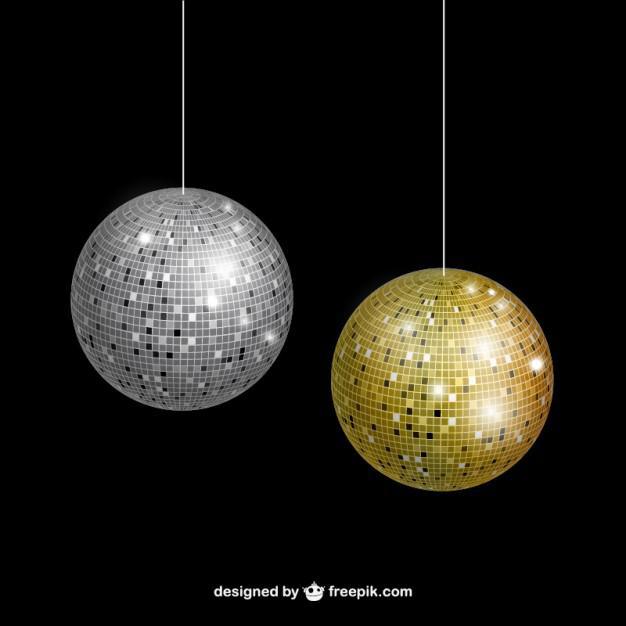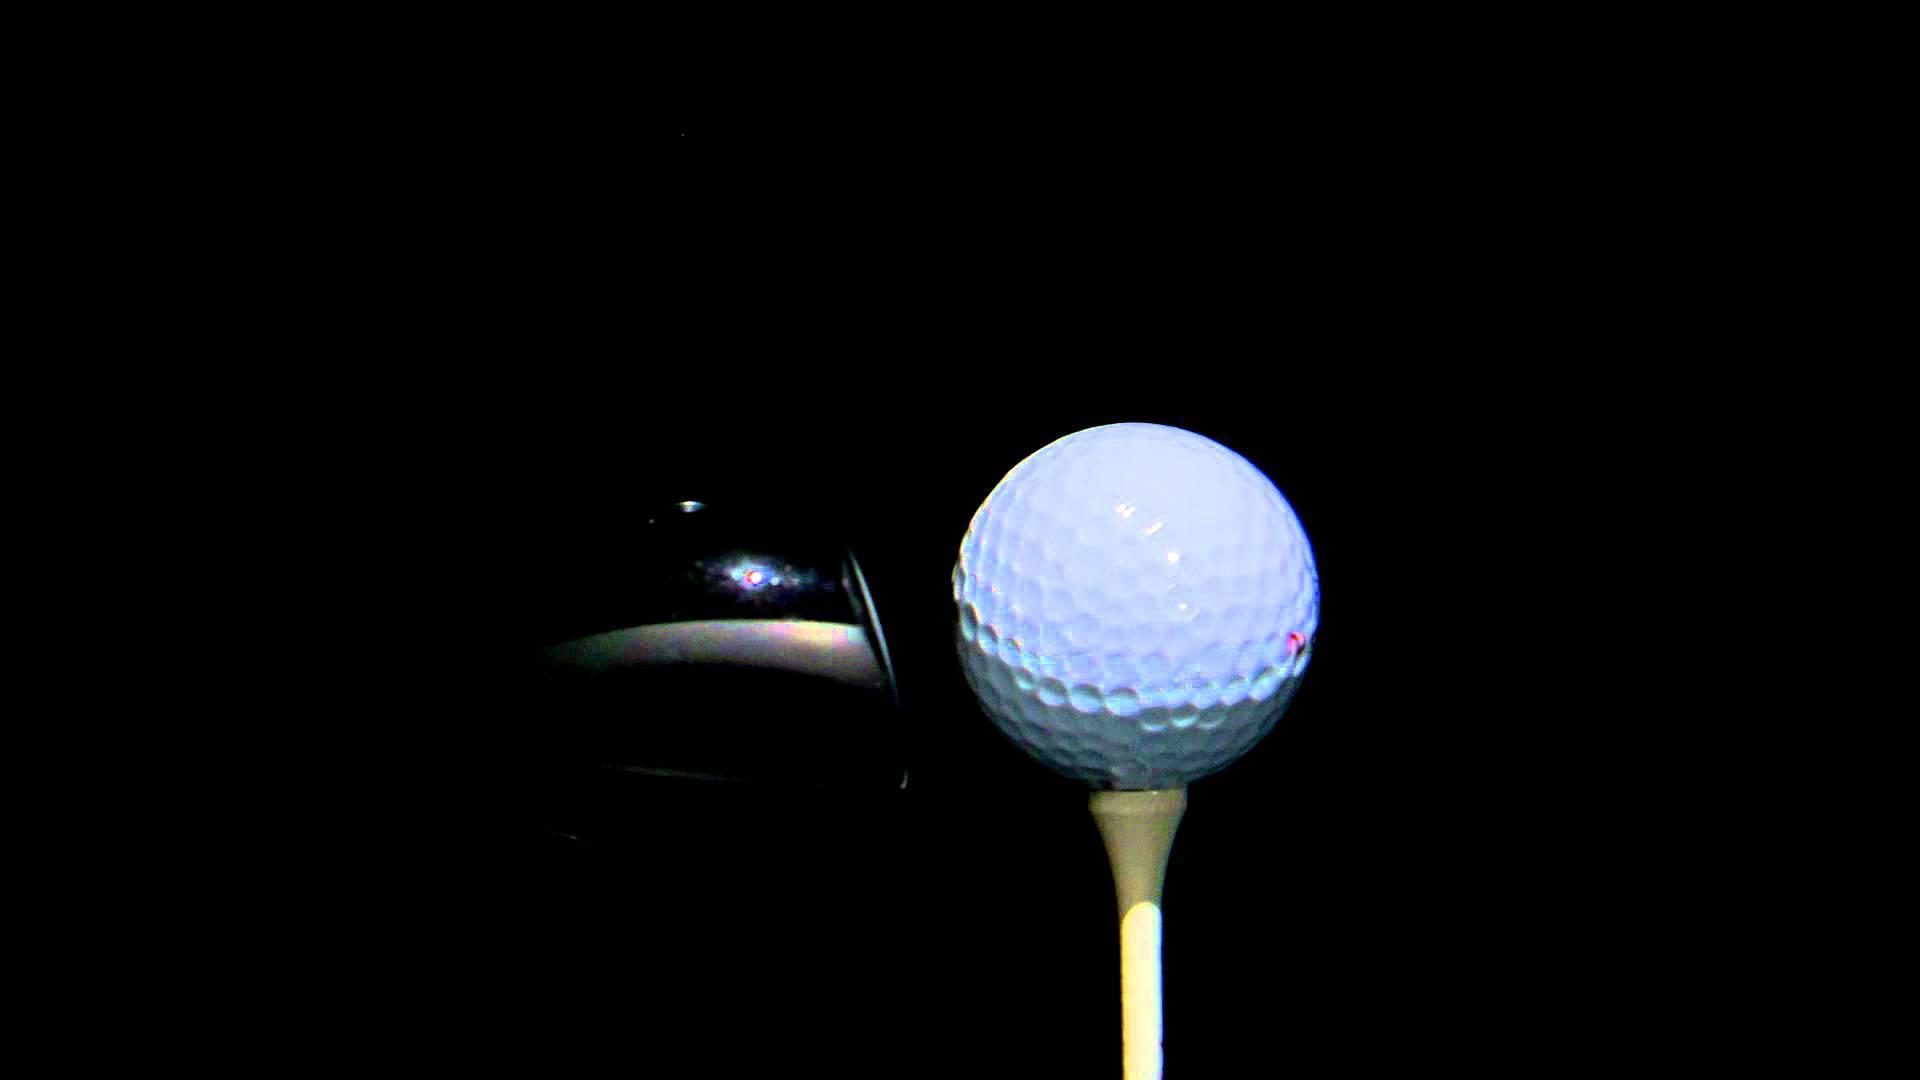The first image is the image on the left, the second image is the image on the right. Analyze the images presented: Is the assertion "The right image contains exactly two golf balls." valid? Answer yes or no. No. The first image is the image on the left, the second image is the image on the right. Assess this claim about the two images: "The right image includes at least one golf tee, and the left image shows a pair of balls side-by-side.". Correct or not? Answer yes or no. Yes. 